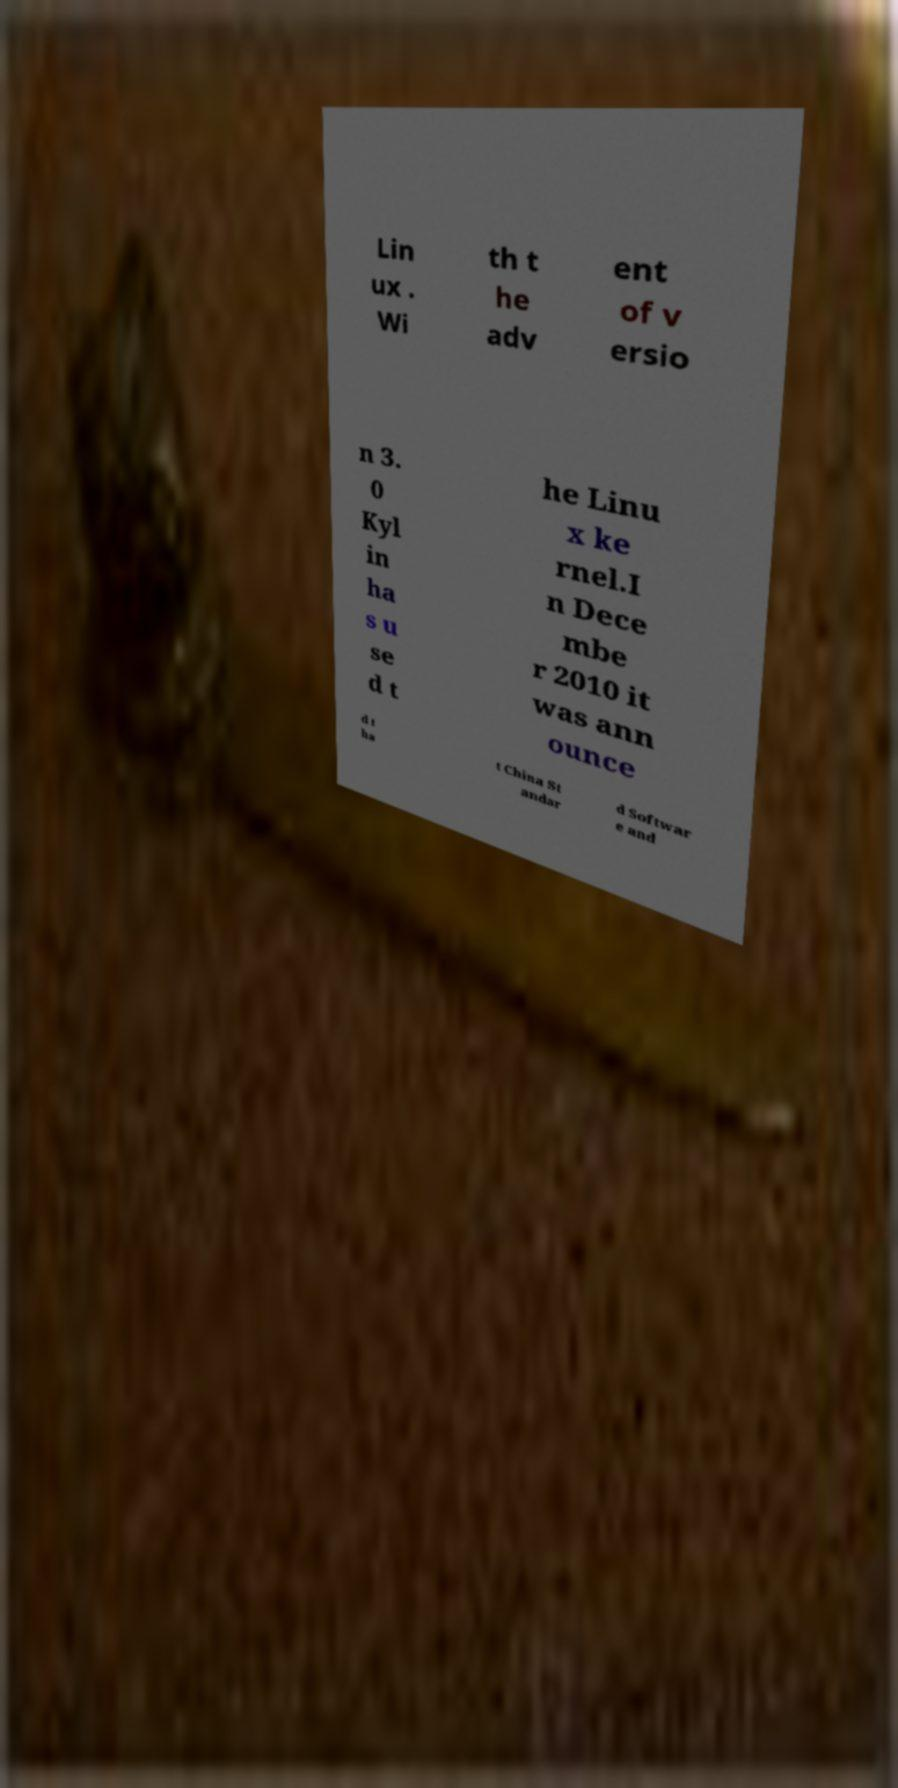Can you accurately transcribe the text from the provided image for me? Lin ux . Wi th t he adv ent of v ersio n 3. 0 Kyl in ha s u se d t he Linu x ke rnel.I n Dece mbe r 2010 it was ann ounce d t ha t China St andar d Softwar e and 